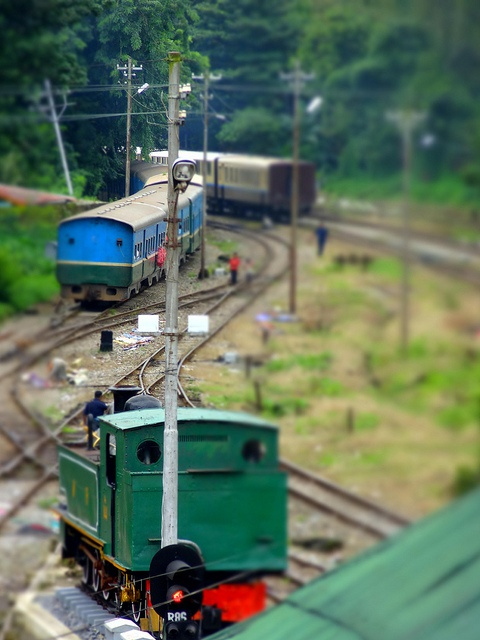Describe the objects in this image and their specific colors. I can see train in black, teal, darkgreen, and gray tones, train in black, gray, lightgray, and blue tones, train in black, gray, and ivory tones, people in black, navy, gray, and maroon tones, and people in black, gray, navy, and darkblue tones in this image. 